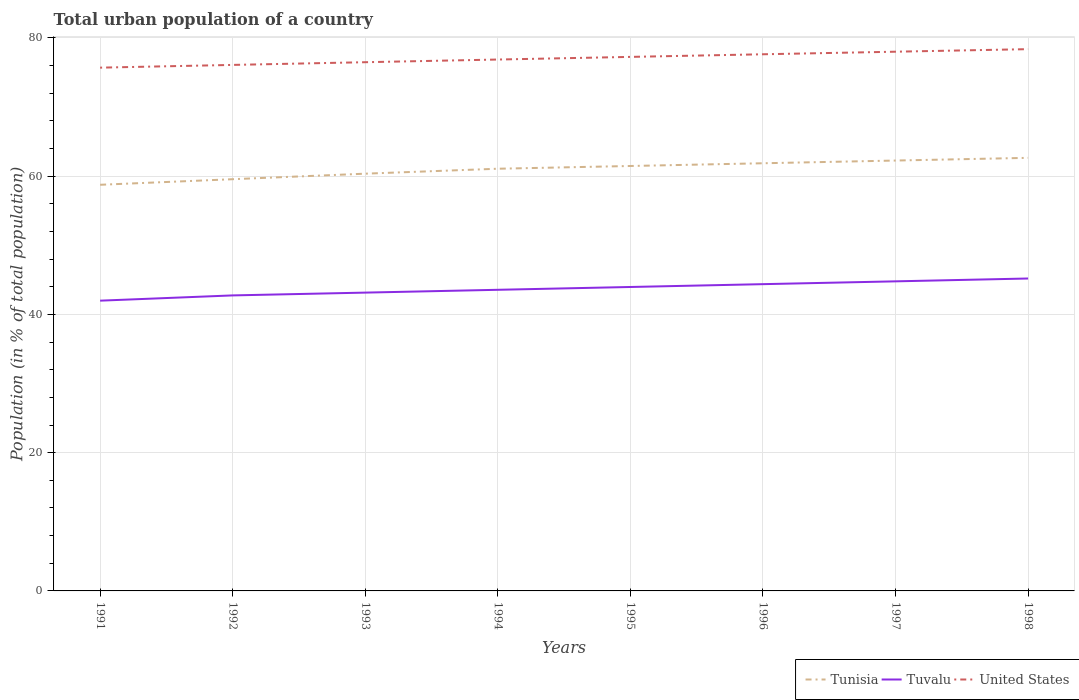How many different coloured lines are there?
Your response must be concise. 3. Does the line corresponding to Tunisia intersect with the line corresponding to Tuvalu?
Your response must be concise. No. Across all years, what is the maximum urban population in Tunisia?
Keep it short and to the point. 58.76. What is the total urban population in United States in the graph?
Ensure brevity in your answer.  -1.5. What is the difference between the highest and the second highest urban population in United States?
Ensure brevity in your answer.  2.68. What is the difference between the highest and the lowest urban population in Tuvalu?
Ensure brevity in your answer.  4. Is the urban population in Tunisia strictly greater than the urban population in United States over the years?
Your response must be concise. Yes. How many years are there in the graph?
Provide a succinct answer. 8. What is the difference between two consecutive major ticks on the Y-axis?
Offer a very short reply. 20. Does the graph contain any zero values?
Offer a very short reply. No. Where does the legend appear in the graph?
Keep it short and to the point. Bottom right. How many legend labels are there?
Provide a short and direct response. 3. What is the title of the graph?
Provide a succinct answer. Total urban population of a country. What is the label or title of the X-axis?
Offer a terse response. Years. What is the label or title of the Y-axis?
Your answer should be very brief. Population (in % of total population). What is the Population (in % of total population) of Tunisia in 1991?
Make the answer very short. 58.76. What is the Population (in % of total population) in Tuvalu in 1991?
Provide a succinct answer. 41.99. What is the Population (in % of total population) in United States in 1991?
Give a very brief answer. 75.7. What is the Population (in % of total population) of Tunisia in 1992?
Your response must be concise. 59.56. What is the Population (in % of total population) of Tuvalu in 1992?
Ensure brevity in your answer.  42.75. What is the Population (in % of total population) in United States in 1992?
Keep it short and to the point. 76.1. What is the Population (in % of total population) in Tunisia in 1993?
Offer a very short reply. 60.36. What is the Population (in % of total population) in Tuvalu in 1993?
Provide a succinct answer. 43.16. What is the Population (in % of total population) of United States in 1993?
Provide a short and direct response. 76.49. What is the Population (in % of total population) in Tunisia in 1994?
Offer a terse response. 61.08. What is the Population (in % of total population) of Tuvalu in 1994?
Offer a terse response. 43.56. What is the Population (in % of total population) of United States in 1994?
Offer a very short reply. 76.88. What is the Population (in % of total population) in Tunisia in 1995?
Provide a short and direct response. 61.47. What is the Population (in % of total population) in Tuvalu in 1995?
Your answer should be compact. 43.97. What is the Population (in % of total population) in United States in 1995?
Your answer should be compact. 77.26. What is the Population (in % of total population) of Tunisia in 1996?
Your answer should be very brief. 61.87. What is the Population (in % of total population) in Tuvalu in 1996?
Give a very brief answer. 44.38. What is the Population (in % of total population) in United States in 1996?
Offer a very short reply. 77.64. What is the Population (in % of total population) of Tunisia in 1997?
Your answer should be very brief. 62.26. What is the Population (in % of total population) of Tuvalu in 1997?
Offer a terse response. 44.79. What is the Population (in % of total population) of United States in 1997?
Offer a very short reply. 78.01. What is the Population (in % of total population) of Tunisia in 1998?
Your answer should be very brief. 62.65. What is the Population (in % of total population) in Tuvalu in 1998?
Provide a succinct answer. 45.2. What is the Population (in % of total population) of United States in 1998?
Keep it short and to the point. 78.38. Across all years, what is the maximum Population (in % of total population) of Tunisia?
Your answer should be compact. 62.65. Across all years, what is the maximum Population (in % of total population) of Tuvalu?
Make the answer very short. 45.2. Across all years, what is the maximum Population (in % of total population) of United States?
Your answer should be very brief. 78.38. Across all years, what is the minimum Population (in % of total population) of Tunisia?
Provide a short and direct response. 58.76. Across all years, what is the minimum Population (in % of total population) in Tuvalu?
Provide a succinct answer. 41.99. Across all years, what is the minimum Population (in % of total population) in United States?
Provide a short and direct response. 75.7. What is the total Population (in % of total population) of Tunisia in the graph?
Ensure brevity in your answer.  488.02. What is the total Population (in % of total population) of Tuvalu in the graph?
Keep it short and to the point. 349.79. What is the total Population (in % of total population) of United States in the graph?
Your answer should be compact. 616.44. What is the difference between the Population (in % of total population) of Tunisia in 1991 and that in 1992?
Provide a succinct answer. -0.81. What is the difference between the Population (in % of total population) of Tuvalu in 1991 and that in 1992?
Your answer should be compact. -0.76. What is the difference between the Population (in % of total population) of United States in 1991 and that in 1992?
Provide a succinct answer. -0.4. What is the difference between the Population (in % of total population) of Tunisia in 1991 and that in 1993?
Give a very brief answer. -1.61. What is the difference between the Population (in % of total population) in Tuvalu in 1991 and that in 1993?
Offer a very short reply. -1.17. What is the difference between the Population (in % of total population) of United States in 1991 and that in 1993?
Keep it short and to the point. -0.79. What is the difference between the Population (in % of total population) in Tunisia in 1991 and that in 1994?
Ensure brevity in your answer.  -2.32. What is the difference between the Population (in % of total population) of Tuvalu in 1991 and that in 1994?
Keep it short and to the point. -1.57. What is the difference between the Population (in % of total population) in United States in 1991 and that in 1994?
Provide a succinct answer. -1.17. What is the difference between the Population (in % of total population) of Tunisia in 1991 and that in 1995?
Provide a short and direct response. -2.72. What is the difference between the Population (in % of total population) of Tuvalu in 1991 and that in 1995?
Keep it short and to the point. -1.98. What is the difference between the Population (in % of total population) in United States in 1991 and that in 1995?
Ensure brevity in your answer.  -1.56. What is the difference between the Population (in % of total population) in Tunisia in 1991 and that in 1996?
Offer a very short reply. -3.11. What is the difference between the Population (in % of total population) of Tuvalu in 1991 and that in 1996?
Ensure brevity in your answer.  -2.39. What is the difference between the Population (in % of total population) of United States in 1991 and that in 1996?
Provide a short and direct response. -1.94. What is the difference between the Population (in % of total population) in Tunisia in 1991 and that in 1997?
Your response must be concise. -3.51. What is the difference between the Population (in % of total population) of Tuvalu in 1991 and that in 1997?
Provide a short and direct response. -2.8. What is the difference between the Population (in % of total population) of United States in 1991 and that in 1997?
Make the answer very short. -2.31. What is the difference between the Population (in % of total population) in Tunisia in 1991 and that in 1998?
Your answer should be very brief. -3.9. What is the difference between the Population (in % of total population) of Tuvalu in 1991 and that in 1998?
Make the answer very short. -3.21. What is the difference between the Population (in % of total population) of United States in 1991 and that in 1998?
Provide a short and direct response. -2.68. What is the difference between the Population (in % of total population) in Tuvalu in 1992 and that in 1993?
Provide a short and direct response. -0.41. What is the difference between the Population (in % of total population) in United States in 1992 and that in 1993?
Provide a succinct answer. -0.39. What is the difference between the Population (in % of total population) of Tunisia in 1992 and that in 1994?
Your response must be concise. -1.52. What is the difference between the Population (in % of total population) in Tuvalu in 1992 and that in 1994?
Offer a terse response. -0.81. What is the difference between the Population (in % of total population) of United States in 1992 and that in 1994?
Keep it short and to the point. -0.78. What is the difference between the Population (in % of total population) in Tunisia in 1992 and that in 1995?
Offer a very short reply. -1.91. What is the difference between the Population (in % of total population) in Tuvalu in 1992 and that in 1995?
Keep it short and to the point. -1.22. What is the difference between the Population (in % of total population) of United States in 1992 and that in 1995?
Your answer should be very brief. -1.16. What is the difference between the Population (in % of total population) of Tunisia in 1992 and that in 1996?
Give a very brief answer. -2.31. What is the difference between the Population (in % of total population) of Tuvalu in 1992 and that in 1996?
Make the answer very short. -1.63. What is the difference between the Population (in % of total population) of United States in 1992 and that in 1996?
Offer a terse response. -1.54. What is the difference between the Population (in % of total population) of Tuvalu in 1992 and that in 1997?
Provide a short and direct response. -2.04. What is the difference between the Population (in % of total population) of United States in 1992 and that in 1997?
Keep it short and to the point. -1.91. What is the difference between the Population (in % of total population) in Tunisia in 1992 and that in 1998?
Provide a succinct answer. -3.09. What is the difference between the Population (in % of total population) in Tuvalu in 1992 and that in 1998?
Offer a terse response. -2.45. What is the difference between the Population (in % of total population) of United States in 1992 and that in 1998?
Offer a terse response. -2.28. What is the difference between the Population (in % of total population) of Tunisia in 1993 and that in 1994?
Your response must be concise. -0.72. What is the difference between the Population (in % of total population) of Tuvalu in 1993 and that in 1994?
Keep it short and to the point. -0.41. What is the difference between the Population (in % of total population) of United States in 1993 and that in 1994?
Offer a terse response. -0.39. What is the difference between the Population (in % of total population) in Tunisia in 1993 and that in 1995?
Your answer should be compact. -1.11. What is the difference between the Population (in % of total population) of Tuvalu in 1993 and that in 1995?
Keep it short and to the point. -0.81. What is the difference between the Population (in % of total population) in United States in 1993 and that in 1995?
Provide a succinct answer. -0.77. What is the difference between the Population (in % of total population) in Tunisia in 1993 and that in 1996?
Offer a terse response. -1.51. What is the difference between the Population (in % of total population) of Tuvalu in 1993 and that in 1996?
Your answer should be very brief. -1.22. What is the difference between the Population (in % of total population) of United States in 1993 and that in 1996?
Offer a very short reply. -1.15. What is the difference between the Population (in % of total population) of Tunisia in 1993 and that in 1997?
Keep it short and to the point. -1.9. What is the difference between the Population (in % of total population) in Tuvalu in 1993 and that in 1997?
Give a very brief answer. -1.63. What is the difference between the Population (in % of total population) of United States in 1993 and that in 1997?
Ensure brevity in your answer.  -1.52. What is the difference between the Population (in % of total population) in Tunisia in 1993 and that in 1998?
Your answer should be very brief. -2.29. What is the difference between the Population (in % of total population) in Tuvalu in 1993 and that in 1998?
Ensure brevity in your answer.  -2.04. What is the difference between the Population (in % of total population) in United States in 1993 and that in 1998?
Offer a very short reply. -1.89. What is the difference between the Population (in % of total population) of Tunisia in 1994 and that in 1995?
Keep it short and to the point. -0.4. What is the difference between the Population (in % of total population) of Tuvalu in 1994 and that in 1995?
Your answer should be compact. -0.41. What is the difference between the Population (in % of total population) in United States in 1994 and that in 1995?
Your answer should be compact. -0.38. What is the difference between the Population (in % of total population) in Tunisia in 1994 and that in 1996?
Your response must be concise. -0.79. What is the difference between the Population (in % of total population) in Tuvalu in 1994 and that in 1996?
Provide a short and direct response. -0.82. What is the difference between the Population (in % of total population) in United States in 1994 and that in 1996?
Make the answer very short. -0.76. What is the difference between the Population (in % of total population) in Tunisia in 1994 and that in 1997?
Offer a terse response. -1.18. What is the difference between the Population (in % of total population) in Tuvalu in 1994 and that in 1997?
Keep it short and to the point. -1.22. What is the difference between the Population (in % of total population) of United States in 1994 and that in 1997?
Your response must be concise. -1.13. What is the difference between the Population (in % of total population) of Tunisia in 1994 and that in 1998?
Provide a short and direct response. -1.57. What is the difference between the Population (in % of total population) of Tuvalu in 1994 and that in 1998?
Keep it short and to the point. -1.63. What is the difference between the Population (in % of total population) of United States in 1994 and that in 1998?
Offer a terse response. -1.5. What is the difference between the Population (in % of total population) in Tunisia in 1995 and that in 1996?
Keep it short and to the point. -0.4. What is the difference between the Population (in % of total population) in Tuvalu in 1995 and that in 1996?
Ensure brevity in your answer.  -0.41. What is the difference between the Population (in % of total population) of United States in 1995 and that in 1996?
Offer a very short reply. -0.38. What is the difference between the Population (in % of total population) in Tunisia in 1995 and that in 1997?
Your answer should be compact. -0.79. What is the difference between the Population (in % of total population) of Tuvalu in 1995 and that in 1997?
Ensure brevity in your answer.  -0.82. What is the difference between the Population (in % of total population) of United States in 1995 and that in 1997?
Keep it short and to the point. -0.75. What is the difference between the Population (in % of total population) of Tunisia in 1995 and that in 1998?
Your response must be concise. -1.18. What is the difference between the Population (in % of total population) in Tuvalu in 1995 and that in 1998?
Offer a very short reply. -1.23. What is the difference between the Population (in % of total population) in United States in 1995 and that in 1998?
Your response must be concise. -1.12. What is the difference between the Population (in % of total population) in Tunisia in 1996 and that in 1997?
Your response must be concise. -0.39. What is the difference between the Population (in % of total population) of Tuvalu in 1996 and that in 1997?
Keep it short and to the point. -0.41. What is the difference between the Population (in % of total population) in United States in 1996 and that in 1997?
Your answer should be very brief. -0.37. What is the difference between the Population (in % of total population) in Tunisia in 1996 and that in 1998?
Offer a very short reply. -0.78. What is the difference between the Population (in % of total population) of Tuvalu in 1996 and that in 1998?
Make the answer very short. -0.82. What is the difference between the Population (in % of total population) in United States in 1996 and that in 1998?
Your answer should be very brief. -0.74. What is the difference between the Population (in % of total population) in Tunisia in 1997 and that in 1998?
Your response must be concise. -0.39. What is the difference between the Population (in % of total population) in Tuvalu in 1997 and that in 1998?
Your answer should be compact. -0.41. What is the difference between the Population (in % of total population) in United States in 1997 and that in 1998?
Your response must be concise. -0.37. What is the difference between the Population (in % of total population) of Tunisia in 1991 and the Population (in % of total population) of Tuvalu in 1992?
Ensure brevity in your answer.  16. What is the difference between the Population (in % of total population) of Tunisia in 1991 and the Population (in % of total population) of United States in 1992?
Offer a very short reply. -17.34. What is the difference between the Population (in % of total population) in Tuvalu in 1991 and the Population (in % of total population) in United States in 1992?
Make the answer very short. -34.11. What is the difference between the Population (in % of total population) of Tunisia in 1991 and the Population (in % of total population) of Tuvalu in 1993?
Your answer should be compact. 15.6. What is the difference between the Population (in % of total population) of Tunisia in 1991 and the Population (in % of total population) of United States in 1993?
Provide a succinct answer. -17.73. What is the difference between the Population (in % of total population) in Tuvalu in 1991 and the Population (in % of total population) in United States in 1993?
Provide a succinct answer. -34.5. What is the difference between the Population (in % of total population) of Tunisia in 1991 and the Population (in % of total population) of Tuvalu in 1994?
Ensure brevity in your answer.  15.19. What is the difference between the Population (in % of total population) in Tunisia in 1991 and the Population (in % of total population) in United States in 1994?
Keep it short and to the point. -18.12. What is the difference between the Population (in % of total population) in Tuvalu in 1991 and the Population (in % of total population) in United States in 1994?
Provide a short and direct response. -34.88. What is the difference between the Population (in % of total population) in Tunisia in 1991 and the Population (in % of total population) in Tuvalu in 1995?
Keep it short and to the point. 14.79. What is the difference between the Population (in % of total population) in Tunisia in 1991 and the Population (in % of total population) in United States in 1995?
Offer a terse response. -18.5. What is the difference between the Population (in % of total population) of Tuvalu in 1991 and the Population (in % of total population) of United States in 1995?
Provide a succinct answer. -35.27. What is the difference between the Population (in % of total population) of Tunisia in 1991 and the Population (in % of total population) of Tuvalu in 1996?
Keep it short and to the point. 14.38. What is the difference between the Population (in % of total population) of Tunisia in 1991 and the Population (in % of total population) of United States in 1996?
Give a very brief answer. -18.88. What is the difference between the Population (in % of total population) in Tuvalu in 1991 and the Population (in % of total population) in United States in 1996?
Your answer should be compact. -35.65. What is the difference between the Population (in % of total population) of Tunisia in 1991 and the Population (in % of total population) of Tuvalu in 1997?
Your response must be concise. 13.97. What is the difference between the Population (in % of total population) of Tunisia in 1991 and the Population (in % of total population) of United States in 1997?
Make the answer very short. -19.25. What is the difference between the Population (in % of total population) of Tuvalu in 1991 and the Population (in % of total population) of United States in 1997?
Offer a terse response. -36.02. What is the difference between the Population (in % of total population) in Tunisia in 1991 and the Population (in % of total population) in Tuvalu in 1998?
Ensure brevity in your answer.  13.56. What is the difference between the Population (in % of total population) in Tunisia in 1991 and the Population (in % of total population) in United States in 1998?
Provide a succinct answer. -19.62. What is the difference between the Population (in % of total population) of Tuvalu in 1991 and the Population (in % of total population) of United States in 1998?
Provide a short and direct response. -36.39. What is the difference between the Population (in % of total population) of Tunisia in 1992 and the Population (in % of total population) of Tuvalu in 1993?
Provide a short and direct response. 16.41. What is the difference between the Population (in % of total population) in Tunisia in 1992 and the Population (in % of total population) in United States in 1993?
Your answer should be compact. -16.93. What is the difference between the Population (in % of total population) of Tuvalu in 1992 and the Population (in % of total population) of United States in 1993?
Provide a short and direct response. -33.74. What is the difference between the Population (in % of total population) of Tunisia in 1992 and the Population (in % of total population) of Tuvalu in 1994?
Make the answer very short. 16. What is the difference between the Population (in % of total population) of Tunisia in 1992 and the Population (in % of total population) of United States in 1994?
Provide a succinct answer. -17.31. What is the difference between the Population (in % of total population) in Tuvalu in 1992 and the Population (in % of total population) in United States in 1994?
Give a very brief answer. -34.12. What is the difference between the Population (in % of total population) of Tunisia in 1992 and the Population (in % of total population) of Tuvalu in 1995?
Your answer should be very brief. 15.59. What is the difference between the Population (in % of total population) in Tunisia in 1992 and the Population (in % of total population) in United States in 1995?
Your answer should be very brief. -17.7. What is the difference between the Population (in % of total population) in Tuvalu in 1992 and the Population (in % of total population) in United States in 1995?
Provide a succinct answer. -34.51. What is the difference between the Population (in % of total population) in Tunisia in 1992 and the Population (in % of total population) in Tuvalu in 1996?
Ensure brevity in your answer.  15.18. What is the difference between the Population (in % of total population) of Tunisia in 1992 and the Population (in % of total population) of United States in 1996?
Keep it short and to the point. -18.07. What is the difference between the Population (in % of total population) of Tuvalu in 1992 and the Population (in % of total population) of United States in 1996?
Provide a succinct answer. -34.88. What is the difference between the Population (in % of total population) in Tunisia in 1992 and the Population (in % of total population) in Tuvalu in 1997?
Give a very brief answer. 14.78. What is the difference between the Population (in % of total population) in Tunisia in 1992 and the Population (in % of total population) in United States in 1997?
Provide a succinct answer. -18.45. What is the difference between the Population (in % of total population) of Tuvalu in 1992 and the Population (in % of total population) of United States in 1997?
Your response must be concise. -35.26. What is the difference between the Population (in % of total population) in Tunisia in 1992 and the Population (in % of total population) in Tuvalu in 1998?
Offer a terse response. 14.37. What is the difference between the Population (in % of total population) of Tunisia in 1992 and the Population (in % of total population) of United States in 1998?
Give a very brief answer. -18.82. What is the difference between the Population (in % of total population) in Tuvalu in 1992 and the Population (in % of total population) in United States in 1998?
Make the answer very short. -35.63. What is the difference between the Population (in % of total population) in Tunisia in 1993 and the Population (in % of total population) in Tuvalu in 1994?
Your answer should be very brief. 16.8. What is the difference between the Population (in % of total population) in Tunisia in 1993 and the Population (in % of total population) in United States in 1994?
Your answer should be very brief. -16.51. What is the difference between the Population (in % of total population) of Tuvalu in 1993 and the Population (in % of total population) of United States in 1994?
Make the answer very short. -33.72. What is the difference between the Population (in % of total population) in Tunisia in 1993 and the Population (in % of total population) in Tuvalu in 1995?
Offer a very short reply. 16.39. What is the difference between the Population (in % of total population) in Tunisia in 1993 and the Population (in % of total population) in United States in 1995?
Your response must be concise. -16.89. What is the difference between the Population (in % of total population) of Tuvalu in 1993 and the Population (in % of total population) of United States in 1995?
Ensure brevity in your answer.  -34.1. What is the difference between the Population (in % of total population) of Tunisia in 1993 and the Population (in % of total population) of Tuvalu in 1996?
Make the answer very short. 15.98. What is the difference between the Population (in % of total population) in Tunisia in 1993 and the Population (in % of total population) in United States in 1996?
Your answer should be compact. -17.27. What is the difference between the Population (in % of total population) in Tuvalu in 1993 and the Population (in % of total population) in United States in 1996?
Offer a terse response. -34.48. What is the difference between the Population (in % of total population) of Tunisia in 1993 and the Population (in % of total population) of Tuvalu in 1997?
Make the answer very short. 15.57. What is the difference between the Population (in % of total population) in Tunisia in 1993 and the Population (in % of total population) in United States in 1997?
Provide a succinct answer. -17.65. What is the difference between the Population (in % of total population) in Tuvalu in 1993 and the Population (in % of total population) in United States in 1997?
Offer a very short reply. -34.85. What is the difference between the Population (in % of total population) of Tunisia in 1993 and the Population (in % of total population) of Tuvalu in 1998?
Ensure brevity in your answer.  15.16. What is the difference between the Population (in % of total population) of Tunisia in 1993 and the Population (in % of total population) of United States in 1998?
Provide a short and direct response. -18.02. What is the difference between the Population (in % of total population) in Tuvalu in 1993 and the Population (in % of total population) in United States in 1998?
Keep it short and to the point. -35.22. What is the difference between the Population (in % of total population) of Tunisia in 1994 and the Population (in % of total population) of Tuvalu in 1995?
Offer a very short reply. 17.11. What is the difference between the Population (in % of total population) in Tunisia in 1994 and the Population (in % of total population) in United States in 1995?
Provide a short and direct response. -16.18. What is the difference between the Population (in % of total population) in Tuvalu in 1994 and the Population (in % of total population) in United States in 1995?
Your answer should be very brief. -33.69. What is the difference between the Population (in % of total population) of Tunisia in 1994 and the Population (in % of total population) of Tuvalu in 1996?
Give a very brief answer. 16.7. What is the difference between the Population (in % of total population) of Tunisia in 1994 and the Population (in % of total population) of United States in 1996?
Offer a very short reply. -16.56. What is the difference between the Population (in % of total population) in Tuvalu in 1994 and the Population (in % of total population) in United States in 1996?
Keep it short and to the point. -34.07. What is the difference between the Population (in % of total population) in Tunisia in 1994 and the Population (in % of total population) in Tuvalu in 1997?
Your response must be concise. 16.29. What is the difference between the Population (in % of total population) in Tunisia in 1994 and the Population (in % of total population) in United States in 1997?
Provide a short and direct response. -16.93. What is the difference between the Population (in % of total population) of Tuvalu in 1994 and the Population (in % of total population) of United States in 1997?
Provide a succinct answer. -34.45. What is the difference between the Population (in % of total population) of Tunisia in 1994 and the Population (in % of total population) of Tuvalu in 1998?
Keep it short and to the point. 15.88. What is the difference between the Population (in % of total population) of Tunisia in 1994 and the Population (in % of total population) of United States in 1998?
Ensure brevity in your answer.  -17.3. What is the difference between the Population (in % of total population) of Tuvalu in 1994 and the Population (in % of total population) of United States in 1998?
Give a very brief answer. -34.81. What is the difference between the Population (in % of total population) in Tunisia in 1995 and the Population (in % of total population) in Tuvalu in 1996?
Ensure brevity in your answer.  17.09. What is the difference between the Population (in % of total population) in Tunisia in 1995 and the Population (in % of total population) in United States in 1996?
Your answer should be very brief. -16.16. What is the difference between the Population (in % of total population) of Tuvalu in 1995 and the Population (in % of total population) of United States in 1996?
Provide a short and direct response. -33.67. What is the difference between the Population (in % of total population) in Tunisia in 1995 and the Population (in % of total population) in Tuvalu in 1997?
Make the answer very short. 16.69. What is the difference between the Population (in % of total population) in Tunisia in 1995 and the Population (in % of total population) in United States in 1997?
Give a very brief answer. -16.53. What is the difference between the Population (in % of total population) of Tuvalu in 1995 and the Population (in % of total population) of United States in 1997?
Your response must be concise. -34.04. What is the difference between the Population (in % of total population) in Tunisia in 1995 and the Population (in % of total population) in Tuvalu in 1998?
Ensure brevity in your answer.  16.28. What is the difference between the Population (in % of total population) in Tunisia in 1995 and the Population (in % of total population) in United States in 1998?
Your response must be concise. -16.9. What is the difference between the Population (in % of total population) of Tuvalu in 1995 and the Population (in % of total population) of United States in 1998?
Ensure brevity in your answer.  -34.41. What is the difference between the Population (in % of total population) of Tunisia in 1996 and the Population (in % of total population) of Tuvalu in 1997?
Keep it short and to the point. 17.08. What is the difference between the Population (in % of total population) of Tunisia in 1996 and the Population (in % of total population) of United States in 1997?
Keep it short and to the point. -16.14. What is the difference between the Population (in % of total population) of Tuvalu in 1996 and the Population (in % of total population) of United States in 1997?
Provide a succinct answer. -33.63. What is the difference between the Population (in % of total population) in Tunisia in 1996 and the Population (in % of total population) in Tuvalu in 1998?
Your answer should be very brief. 16.67. What is the difference between the Population (in % of total population) in Tunisia in 1996 and the Population (in % of total population) in United States in 1998?
Your answer should be compact. -16.51. What is the difference between the Population (in % of total population) in Tuvalu in 1996 and the Population (in % of total population) in United States in 1998?
Your answer should be compact. -34. What is the difference between the Population (in % of total population) in Tunisia in 1997 and the Population (in % of total population) in Tuvalu in 1998?
Provide a succinct answer. 17.07. What is the difference between the Population (in % of total population) in Tunisia in 1997 and the Population (in % of total population) in United States in 1998?
Keep it short and to the point. -16.11. What is the difference between the Population (in % of total population) of Tuvalu in 1997 and the Population (in % of total population) of United States in 1998?
Your response must be concise. -33.59. What is the average Population (in % of total population) of Tunisia per year?
Provide a succinct answer. 61. What is the average Population (in % of total population) of Tuvalu per year?
Give a very brief answer. 43.72. What is the average Population (in % of total population) in United States per year?
Provide a short and direct response. 77.05. In the year 1991, what is the difference between the Population (in % of total population) of Tunisia and Population (in % of total population) of Tuvalu?
Provide a succinct answer. 16.77. In the year 1991, what is the difference between the Population (in % of total population) in Tunisia and Population (in % of total population) in United States?
Make the answer very short. -16.95. In the year 1991, what is the difference between the Population (in % of total population) of Tuvalu and Population (in % of total population) of United States?
Provide a succinct answer. -33.71. In the year 1992, what is the difference between the Population (in % of total population) of Tunisia and Population (in % of total population) of Tuvalu?
Your response must be concise. 16.81. In the year 1992, what is the difference between the Population (in % of total population) in Tunisia and Population (in % of total population) in United States?
Ensure brevity in your answer.  -16.54. In the year 1992, what is the difference between the Population (in % of total population) of Tuvalu and Population (in % of total population) of United States?
Provide a succinct answer. -33.35. In the year 1993, what is the difference between the Population (in % of total population) in Tunisia and Population (in % of total population) in Tuvalu?
Offer a very short reply. 17.21. In the year 1993, what is the difference between the Population (in % of total population) of Tunisia and Population (in % of total population) of United States?
Offer a very short reply. -16.13. In the year 1993, what is the difference between the Population (in % of total population) in Tuvalu and Population (in % of total population) in United States?
Your answer should be compact. -33.33. In the year 1994, what is the difference between the Population (in % of total population) in Tunisia and Population (in % of total population) in Tuvalu?
Ensure brevity in your answer.  17.52. In the year 1994, what is the difference between the Population (in % of total population) in Tunisia and Population (in % of total population) in United States?
Your response must be concise. -15.8. In the year 1994, what is the difference between the Population (in % of total population) in Tuvalu and Population (in % of total population) in United States?
Provide a short and direct response. -33.31. In the year 1995, what is the difference between the Population (in % of total population) of Tunisia and Population (in % of total population) of Tuvalu?
Provide a succinct answer. 17.5. In the year 1995, what is the difference between the Population (in % of total population) of Tunisia and Population (in % of total population) of United States?
Provide a short and direct response. -15.78. In the year 1995, what is the difference between the Population (in % of total population) of Tuvalu and Population (in % of total population) of United States?
Ensure brevity in your answer.  -33.29. In the year 1996, what is the difference between the Population (in % of total population) in Tunisia and Population (in % of total population) in Tuvalu?
Your response must be concise. 17.49. In the year 1996, what is the difference between the Population (in % of total population) of Tunisia and Population (in % of total population) of United States?
Keep it short and to the point. -15.77. In the year 1996, what is the difference between the Population (in % of total population) in Tuvalu and Population (in % of total population) in United States?
Your answer should be very brief. -33.26. In the year 1997, what is the difference between the Population (in % of total population) of Tunisia and Population (in % of total population) of Tuvalu?
Offer a very short reply. 17.48. In the year 1997, what is the difference between the Population (in % of total population) in Tunisia and Population (in % of total population) in United States?
Your answer should be very brief. -15.75. In the year 1997, what is the difference between the Population (in % of total population) in Tuvalu and Population (in % of total population) in United States?
Your answer should be compact. -33.22. In the year 1998, what is the difference between the Population (in % of total population) of Tunisia and Population (in % of total population) of Tuvalu?
Keep it short and to the point. 17.46. In the year 1998, what is the difference between the Population (in % of total population) of Tunisia and Population (in % of total population) of United States?
Your answer should be very brief. -15.72. In the year 1998, what is the difference between the Population (in % of total population) in Tuvalu and Population (in % of total population) in United States?
Your answer should be very brief. -33.18. What is the ratio of the Population (in % of total population) of Tunisia in 1991 to that in 1992?
Provide a succinct answer. 0.99. What is the ratio of the Population (in % of total population) of Tuvalu in 1991 to that in 1992?
Your answer should be compact. 0.98. What is the ratio of the Population (in % of total population) of Tunisia in 1991 to that in 1993?
Ensure brevity in your answer.  0.97. What is the ratio of the Population (in % of total population) of Tuvalu in 1991 to that in 1993?
Offer a very short reply. 0.97. What is the ratio of the Population (in % of total population) in United States in 1991 to that in 1993?
Ensure brevity in your answer.  0.99. What is the ratio of the Population (in % of total population) in Tuvalu in 1991 to that in 1994?
Offer a very short reply. 0.96. What is the ratio of the Population (in % of total population) of United States in 1991 to that in 1994?
Ensure brevity in your answer.  0.98. What is the ratio of the Population (in % of total population) of Tunisia in 1991 to that in 1995?
Provide a short and direct response. 0.96. What is the ratio of the Population (in % of total population) of Tuvalu in 1991 to that in 1995?
Make the answer very short. 0.95. What is the ratio of the Population (in % of total population) in United States in 1991 to that in 1995?
Your answer should be compact. 0.98. What is the ratio of the Population (in % of total population) in Tunisia in 1991 to that in 1996?
Keep it short and to the point. 0.95. What is the ratio of the Population (in % of total population) of Tuvalu in 1991 to that in 1996?
Your response must be concise. 0.95. What is the ratio of the Population (in % of total population) of United States in 1991 to that in 1996?
Ensure brevity in your answer.  0.98. What is the ratio of the Population (in % of total population) in Tunisia in 1991 to that in 1997?
Your answer should be very brief. 0.94. What is the ratio of the Population (in % of total population) in Tuvalu in 1991 to that in 1997?
Provide a short and direct response. 0.94. What is the ratio of the Population (in % of total population) of United States in 1991 to that in 1997?
Provide a short and direct response. 0.97. What is the ratio of the Population (in % of total population) in Tunisia in 1991 to that in 1998?
Ensure brevity in your answer.  0.94. What is the ratio of the Population (in % of total population) of Tuvalu in 1991 to that in 1998?
Give a very brief answer. 0.93. What is the ratio of the Population (in % of total population) in United States in 1991 to that in 1998?
Offer a very short reply. 0.97. What is the ratio of the Population (in % of total population) in Tunisia in 1992 to that in 1993?
Offer a very short reply. 0.99. What is the ratio of the Population (in % of total population) in Tuvalu in 1992 to that in 1993?
Your response must be concise. 0.99. What is the ratio of the Population (in % of total population) of United States in 1992 to that in 1993?
Offer a very short reply. 0.99. What is the ratio of the Population (in % of total population) in Tunisia in 1992 to that in 1994?
Your response must be concise. 0.98. What is the ratio of the Population (in % of total population) in Tuvalu in 1992 to that in 1994?
Give a very brief answer. 0.98. What is the ratio of the Population (in % of total population) in Tunisia in 1992 to that in 1995?
Offer a terse response. 0.97. What is the ratio of the Population (in % of total population) of Tuvalu in 1992 to that in 1995?
Provide a succinct answer. 0.97. What is the ratio of the Population (in % of total population) in Tunisia in 1992 to that in 1996?
Offer a very short reply. 0.96. What is the ratio of the Population (in % of total population) in Tuvalu in 1992 to that in 1996?
Your answer should be compact. 0.96. What is the ratio of the Population (in % of total population) of United States in 1992 to that in 1996?
Offer a very short reply. 0.98. What is the ratio of the Population (in % of total population) of Tunisia in 1992 to that in 1997?
Ensure brevity in your answer.  0.96. What is the ratio of the Population (in % of total population) of Tuvalu in 1992 to that in 1997?
Ensure brevity in your answer.  0.95. What is the ratio of the Population (in % of total population) in United States in 1992 to that in 1997?
Ensure brevity in your answer.  0.98. What is the ratio of the Population (in % of total population) of Tunisia in 1992 to that in 1998?
Your answer should be very brief. 0.95. What is the ratio of the Population (in % of total population) of Tuvalu in 1992 to that in 1998?
Ensure brevity in your answer.  0.95. What is the ratio of the Population (in % of total population) in United States in 1992 to that in 1998?
Give a very brief answer. 0.97. What is the ratio of the Population (in % of total population) of Tunisia in 1993 to that in 1994?
Provide a short and direct response. 0.99. What is the ratio of the Population (in % of total population) in United States in 1993 to that in 1994?
Ensure brevity in your answer.  0.99. What is the ratio of the Population (in % of total population) in Tunisia in 1993 to that in 1995?
Offer a very short reply. 0.98. What is the ratio of the Population (in % of total population) in Tuvalu in 1993 to that in 1995?
Your response must be concise. 0.98. What is the ratio of the Population (in % of total population) of United States in 1993 to that in 1995?
Provide a succinct answer. 0.99. What is the ratio of the Population (in % of total population) of Tunisia in 1993 to that in 1996?
Your answer should be very brief. 0.98. What is the ratio of the Population (in % of total population) in Tuvalu in 1993 to that in 1996?
Your response must be concise. 0.97. What is the ratio of the Population (in % of total population) of United States in 1993 to that in 1996?
Keep it short and to the point. 0.99. What is the ratio of the Population (in % of total population) in Tunisia in 1993 to that in 1997?
Provide a succinct answer. 0.97. What is the ratio of the Population (in % of total population) of Tuvalu in 1993 to that in 1997?
Your answer should be very brief. 0.96. What is the ratio of the Population (in % of total population) in United States in 1993 to that in 1997?
Make the answer very short. 0.98. What is the ratio of the Population (in % of total population) of Tunisia in 1993 to that in 1998?
Provide a succinct answer. 0.96. What is the ratio of the Population (in % of total population) of Tuvalu in 1993 to that in 1998?
Keep it short and to the point. 0.95. What is the ratio of the Population (in % of total population) of United States in 1993 to that in 1998?
Keep it short and to the point. 0.98. What is the ratio of the Population (in % of total population) of Tunisia in 1994 to that in 1995?
Make the answer very short. 0.99. What is the ratio of the Population (in % of total population) in Tuvalu in 1994 to that in 1995?
Keep it short and to the point. 0.99. What is the ratio of the Population (in % of total population) of United States in 1994 to that in 1995?
Keep it short and to the point. 1. What is the ratio of the Population (in % of total population) in Tunisia in 1994 to that in 1996?
Your response must be concise. 0.99. What is the ratio of the Population (in % of total population) of Tuvalu in 1994 to that in 1996?
Provide a short and direct response. 0.98. What is the ratio of the Population (in % of total population) in United States in 1994 to that in 1996?
Keep it short and to the point. 0.99. What is the ratio of the Population (in % of total population) of Tuvalu in 1994 to that in 1997?
Ensure brevity in your answer.  0.97. What is the ratio of the Population (in % of total population) in United States in 1994 to that in 1997?
Provide a succinct answer. 0.99. What is the ratio of the Population (in % of total population) of Tunisia in 1994 to that in 1998?
Give a very brief answer. 0.97. What is the ratio of the Population (in % of total population) of Tuvalu in 1994 to that in 1998?
Make the answer very short. 0.96. What is the ratio of the Population (in % of total population) of United States in 1994 to that in 1998?
Provide a succinct answer. 0.98. What is the ratio of the Population (in % of total population) in Tuvalu in 1995 to that in 1996?
Your answer should be compact. 0.99. What is the ratio of the Population (in % of total population) in Tunisia in 1995 to that in 1997?
Your answer should be very brief. 0.99. What is the ratio of the Population (in % of total population) in Tuvalu in 1995 to that in 1997?
Your answer should be very brief. 0.98. What is the ratio of the Population (in % of total population) of Tunisia in 1995 to that in 1998?
Provide a short and direct response. 0.98. What is the ratio of the Population (in % of total population) in Tuvalu in 1995 to that in 1998?
Give a very brief answer. 0.97. What is the ratio of the Population (in % of total population) in United States in 1995 to that in 1998?
Give a very brief answer. 0.99. What is the ratio of the Population (in % of total population) in Tuvalu in 1996 to that in 1997?
Your response must be concise. 0.99. What is the ratio of the Population (in % of total population) in United States in 1996 to that in 1997?
Offer a terse response. 1. What is the ratio of the Population (in % of total population) of Tunisia in 1996 to that in 1998?
Provide a succinct answer. 0.99. What is the ratio of the Population (in % of total population) of Tuvalu in 1996 to that in 1998?
Ensure brevity in your answer.  0.98. What is the ratio of the Population (in % of total population) of Tunisia in 1997 to that in 1998?
Offer a very short reply. 0.99. What is the ratio of the Population (in % of total population) of Tuvalu in 1997 to that in 1998?
Offer a very short reply. 0.99. What is the ratio of the Population (in % of total population) in United States in 1997 to that in 1998?
Make the answer very short. 1. What is the difference between the highest and the second highest Population (in % of total population) of Tunisia?
Provide a short and direct response. 0.39. What is the difference between the highest and the second highest Population (in % of total population) of Tuvalu?
Your response must be concise. 0.41. What is the difference between the highest and the second highest Population (in % of total population) of United States?
Provide a short and direct response. 0.37. What is the difference between the highest and the lowest Population (in % of total population) in Tunisia?
Your answer should be very brief. 3.9. What is the difference between the highest and the lowest Population (in % of total population) in Tuvalu?
Give a very brief answer. 3.21. What is the difference between the highest and the lowest Population (in % of total population) of United States?
Your answer should be compact. 2.68. 